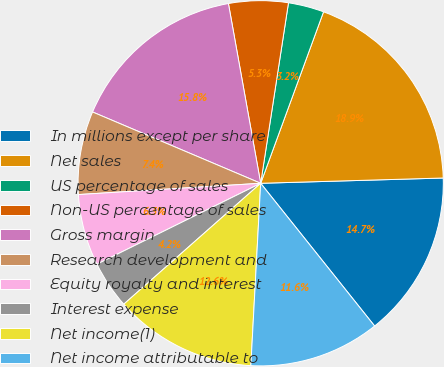Convert chart to OTSL. <chart><loc_0><loc_0><loc_500><loc_500><pie_chart><fcel>In millions except per share<fcel>Net sales<fcel>US percentage of sales<fcel>Non-US percentage of sales<fcel>Gross margin<fcel>Research development and<fcel>Equity royalty and interest<fcel>Interest expense<fcel>Net income(1)<fcel>Net income attributable to<nl><fcel>14.74%<fcel>18.95%<fcel>3.16%<fcel>5.26%<fcel>15.79%<fcel>7.37%<fcel>6.32%<fcel>4.21%<fcel>12.63%<fcel>11.58%<nl></chart> 